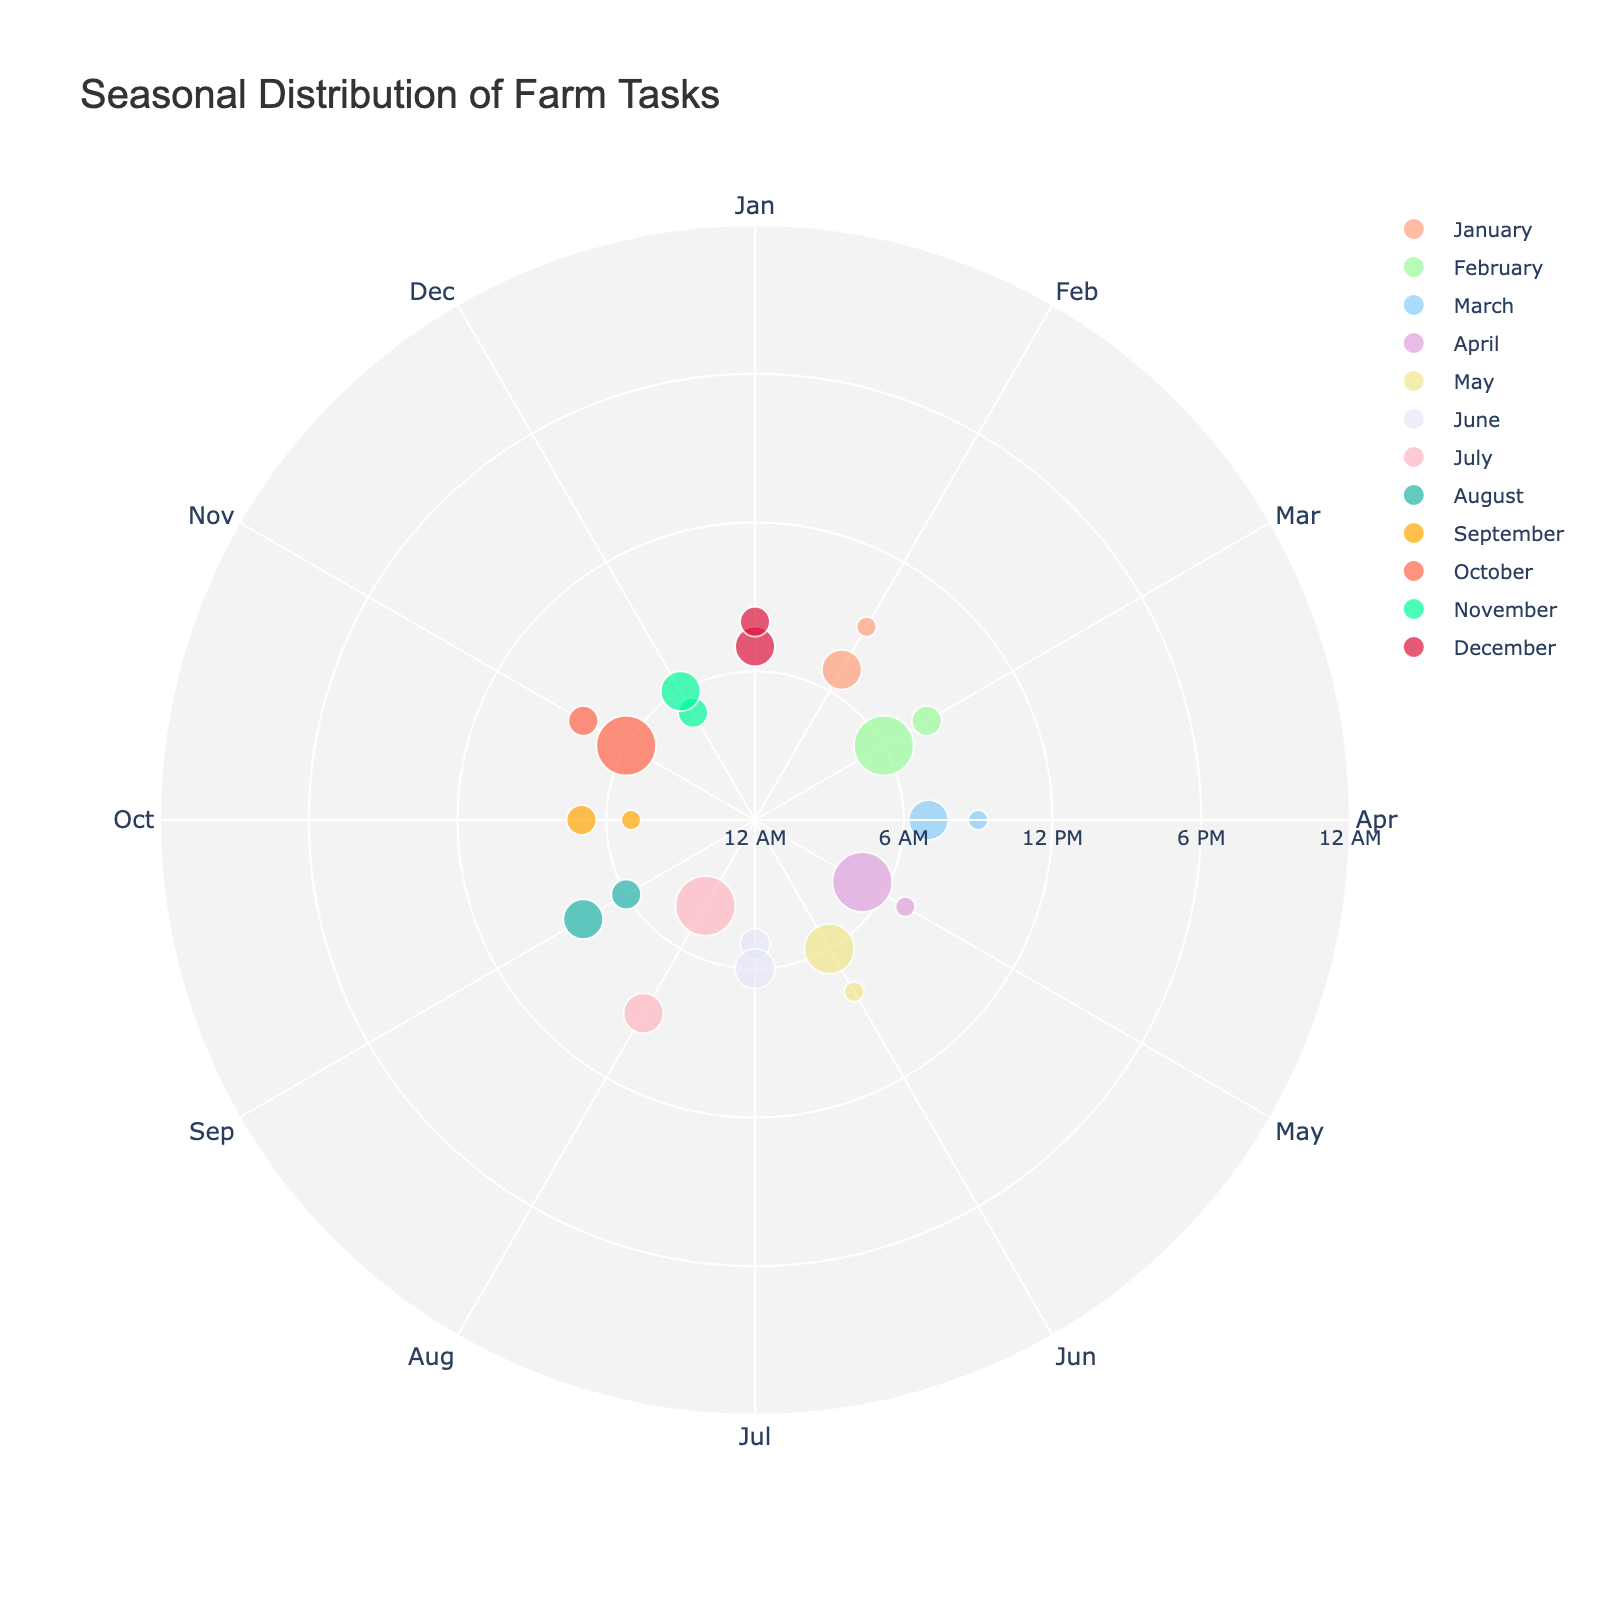What is the title of the Polar Scatter Chart? The title of the chart is displayed prominently at the top. By referring to this location on the figure, you can easily find this information.
Answer: Seasonal Distribution of Farm Tasks Which month shows the task of "Composting"? Locate the text annotations around the perimeter of the chart, which consist of the tasks associated with each data point. Find the task "Composting," and its radial position will indicate the month.
Answer: September What color represents tasks in April? Tasks in each month are represented by different colors. By identifying the month “April” and observing the color of its data points, we can determine the corresponding color.
Answer: Yellow Which month has the most data points representing farm tasks? By counting the number of data points for each month, you can determine which month has the highest frequency of tasks.
Answer: January What is the task with the longest duration in February? Examine the data points for February and identify which one has the largest marker size (duration * 10), which indicates the longest task duration.
Answer: Early Spring Planting Which hour has the most tasks occurring across all months? Look at the radial axis values (hours) and count how many tasks occur at each specific hour to see which hour appears most frequently.
Answer: 6 AM How many tasks are there between 5 AM and 10 AM in May? Focus on the data points that fall within the radial range of 5 AM to 10 AM in the month of May, then count them.
Answer: 2 Compare the durations of tasks related to animal care (e.g., Feeding Cattle, Milking Cows) and plant care (e.g., Weeding, Irrigation Setup) across all months. Which category has the longer total duration? Identify and sum up the durations of all tasks related to animal care and do the same for plant care. Compare the total durations of each category to find the answer.
Answer: Animal care Which task appears in both January and March? Look for common tasks in both the data points marked for January and March, comparing the text annotations.
Answer: Feeding Cattle In which month does the first task of the day occur the earliest? Identify the earliest hour tasks for each month by looking at the radial axis values and find the minimum hour value among them.
Answer: April 